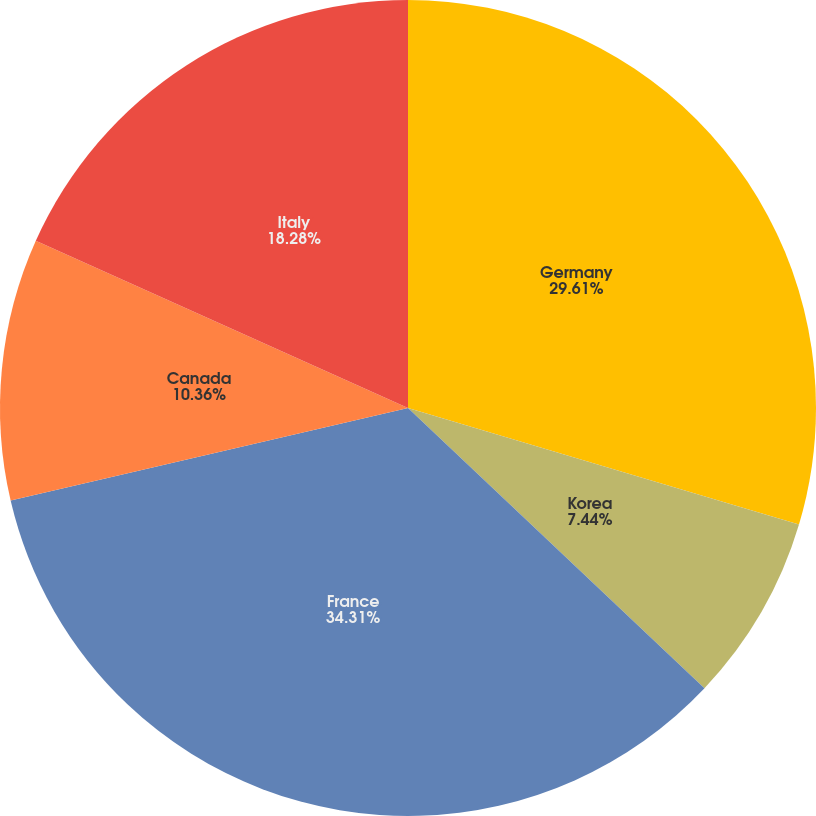Convert chart. <chart><loc_0><loc_0><loc_500><loc_500><pie_chart><fcel>Germany<fcel>Korea<fcel>France<fcel>Canada<fcel>Italy<nl><fcel>29.61%<fcel>7.44%<fcel>34.3%<fcel>10.36%<fcel>18.28%<nl></chart> 